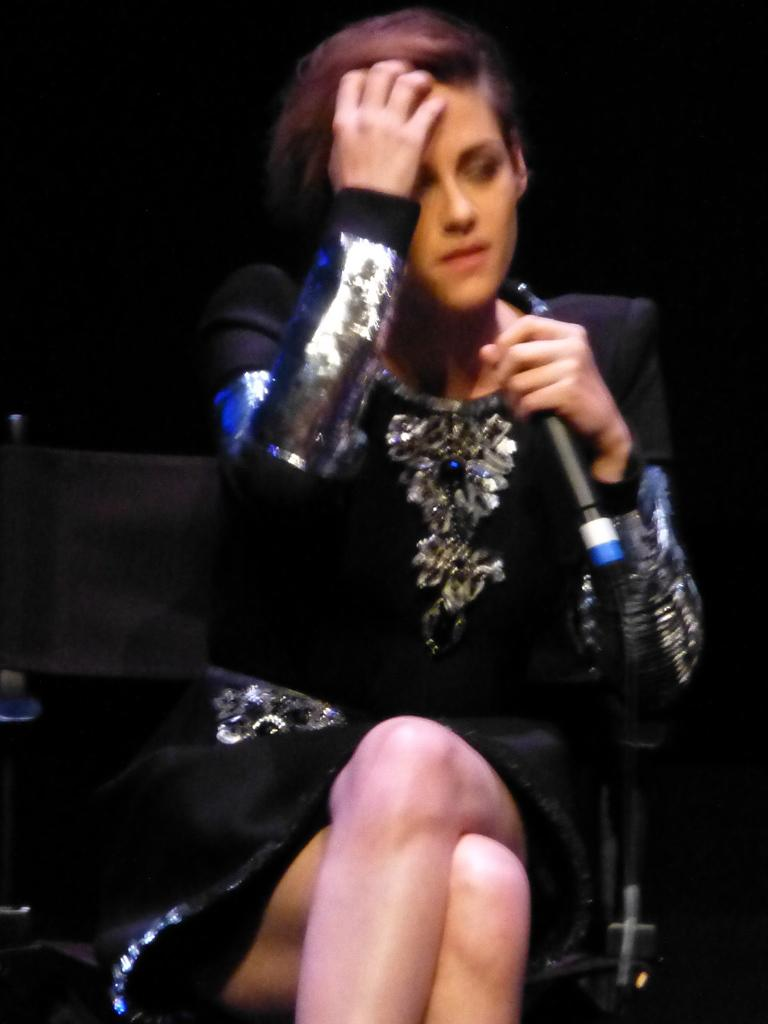Who is the main subject in the image? There is a woman in the image. What is the woman doing in the image? The woman is sitting on a chair and holding a microphone. What can be observed about the background of the image? The background of the image is dark. What type of vest is the woman wearing in the image? There is no vest visible in the image; the woman is holding a microphone while sitting on a chair. 